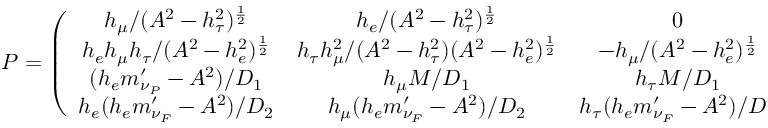Convert formula to latex. <formula><loc_0><loc_0><loc_500><loc_500>P = \left ( \begin{array} { c c c c } { { h _ { \mu } / ( A ^ { 2 } - h _ { \tau } ^ { 2 } ) ^ { \frac { 1 } { 2 } } } } & { { h _ { e } / ( A ^ { 2 } - h _ { \tau } ^ { 2 } ) ^ { \frac { 1 } { 2 } } } } & { 0 } & { 0 } \\ { { h _ { e } h _ { \mu } h _ { \tau } / ( A ^ { 2 } - h _ { e } ^ { 2 } ) ^ { \frac { 1 } { 2 } } } } & { { h _ { \tau } h _ { \mu } ^ { 2 } / ( A ^ { 2 } - h _ { \tau } ^ { 2 } ) ( A ^ { 2 } - h _ { e } ^ { 2 } ) ^ { \frac { 1 } { 2 } } } } & { { - h _ { \mu } / ( A ^ { 2 } - h _ { e } ^ { 2 } ) ^ { \frac { 1 } { 2 } } } } & { 0 } \\ { { ( h _ { e } m _ { \nu _ { P } } ^ { \prime } - A ^ { 2 } ) / D _ { 1 } } } & { { h _ { \mu } M / D _ { 1 } } } & { { h _ { \tau } M / D _ { 1 } } } & { { h _ { e } M / D _ { 1 } } } \\ { { h _ { e } ( h _ { e } m _ { \nu _ { F } } ^ { \prime } - A ^ { 2 } ) / D _ { 2 } } } & { { h _ { \mu } ( h _ { e } m _ { \nu _ { F } } ^ { \prime } - A ^ { 2 } ) / D _ { 2 } } } & { { h _ { \tau } ( h _ { e } m _ { \nu _ { F } } ^ { \prime } - A ^ { 2 } ) / D _ { 2 } } } & { { - A M ( h _ { e } m _ { \nu _ { F } } ^ { \prime } - A ^ { 2 } ) / D _ { 2 } } } \end{array} \right )</formula> 